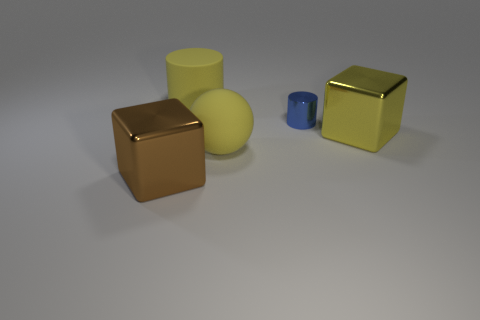Add 4 yellow matte balls. How many objects exist? 9 Subtract all red spheres. How many blue blocks are left? 0 Subtract all small blue matte blocks. Subtract all yellow rubber things. How many objects are left? 3 Add 3 blue cylinders. How many blue cylinders are left? 4 Add 1 spheres. How many spheres exist? 2 Subtract all brown blocks. How many blocks are left? 1 Subtract 0 brown cylinders. How many objects are left? 5 Subtract all cubes. How many objects are left? 3 Subtract 2 cylinders. How many cylinders are left? 0 Subtract all purple cubes. Subtract all yellow balls. How many cubes are left? 2 